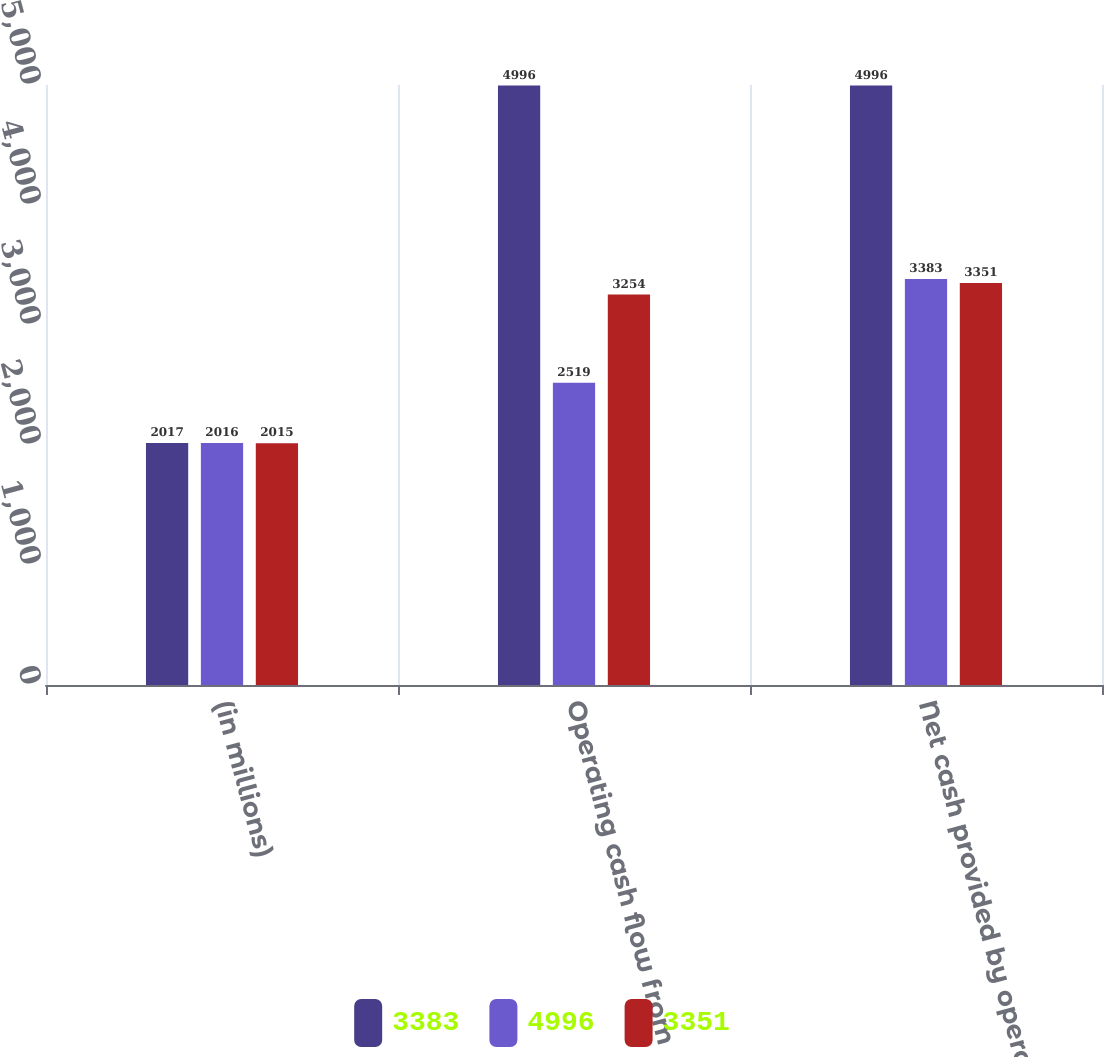Convert chart to OTSL. <chart><loc_0><loc_0><loc_500><loc_500><stacked_bar_chart><ecel><fcel>(in millions)<fcel>Operating cash flow from<fcel>Net cash provided by operating<nl><fcel>3383<fcel>2017<fcel>4996<fcel>4996<nl><fcel>4996<fcel>2016<fcel>2519<fcel>3383<nl><fcel>3351<fcel>2015<fcel>3254<fcel>3351<nl></chart> 